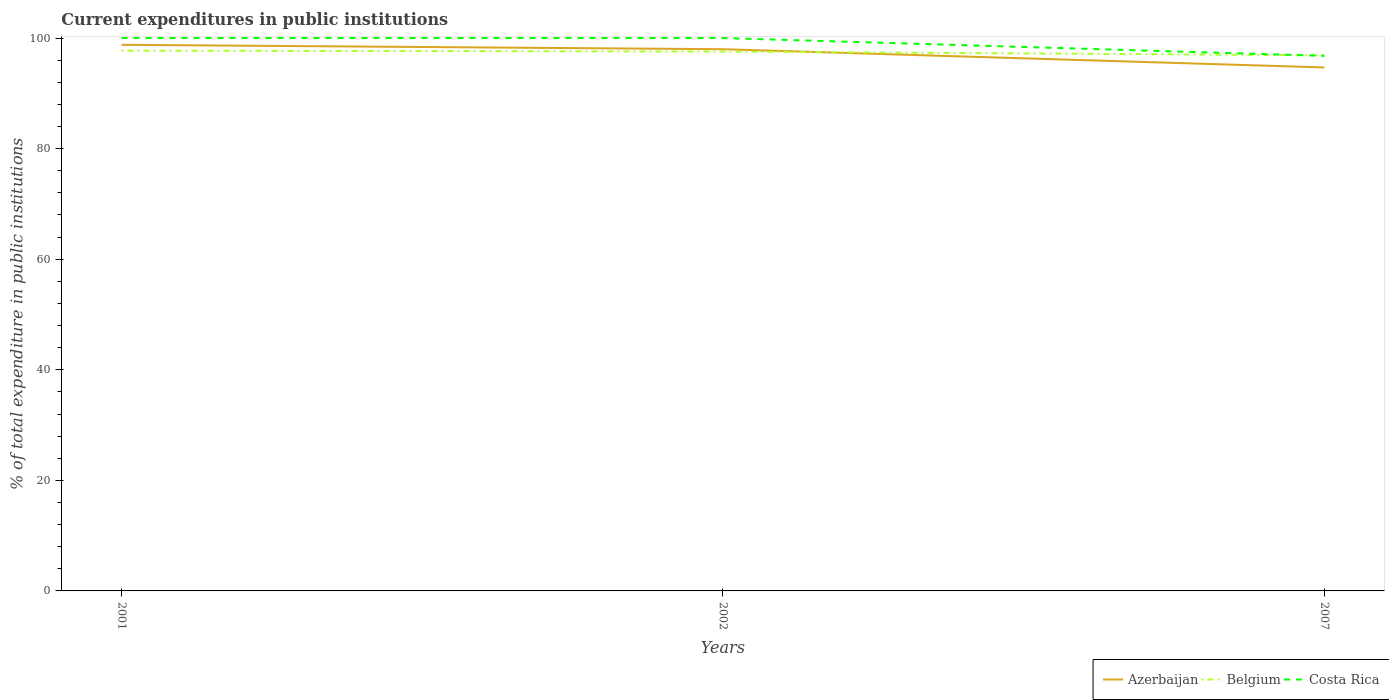How many different coloured lines are there?
Offer a very short reply. 3. Does the line corresponding to Costa Rica intersect with the line corresponding to Belgium?
Provide a short and direct response. Yes. Across all years, what is the maximum current expenditures in public institutions in Azerbaijan?
Your response must be concise. 94.68. In which year was the current expenditures in public institutions in Belgium maximum?
Keep it short and to the point. 2007. What is the difference between the highest and the second highest current expenditures in public institutions in Costa Rica?
Offer a terse response. 3.22. Is the current expenditures in public institutions in Costa Rica strictly greater than the current expenditures in public institutions in Belgium over the years?
Provide a short and direct response. No. What is the difference between two consecutive major ticks on the Y-axis?
Make the answer very short. 20. Does the graph contain grids?
Provide a succinct answer. No. Where does the legend appear in the graph?
Your answer should be very brief. Bottom right. How are the legend labels stacked?
Provide a succinct answer. Horizontal. What is the title of the graph?
Keep it short and to the point. Current expenditures in public institutions. What is the label or title of the X-axis?
Keep it short and to the point. Years. What is the label or title of the Y-axis?
Offer a very short reply. % of total expenditure in public institutions. What is the % of total expenditure in public institutions of Azerbaijan in 2001?
Offer a very short reply. 98.78. What is the % of total expenditure in public institutions in Belgium in 2001?
Give a very brief answer. 97.72. What is the % of total expenditure in public institutions of Costa Rica in 2001?
Give a very brief answer. 100. What is the % of total expenditure in public institutions of Azerbaijan in 2002?
Keep it short and to the point. 97.98. What is the % of total expenditure in public institutions in Belgium in 2002?
Your answer should be compact. 97.56. What is the % of total expenditure in public institutions of Costa Rica in 2002?
Provide a short and direct response. 100. What is the % of total expenditure in public institutions in Azerbaijan in 2007?
Your response must be concise. 94.68. What is the % of total expenditure in public institutions of Belgium in 2007?
Offer a very short reply. 96.88. What is the % of total expenditure in public institutions of Costa Rica in 2007?
Provide a short and direct response. 96.78. Across all years, what is the maximum % of total expenditure in public institutions in Azerbaijan?
Keep it short and to the point. 98.78. Across all years, what is the maximum % of total expenditure in public institutions of Belgium?
Your response must be concise. 97.72. Across all years, what is the minimum % of total expenditure in public institutions in Azerbaijan?
Offer a very short reply. 94.68. Across all years, what is the minimum % of total expenditure in public institutions in Belgium?
Offer a terse response. 96.88. Across all years, what is the minimum % of total expenditure in public institutions in Costa Rica?
Offer a terse response. 96.78. What is the total % of total expenditure in public institutions of Azerbaijan in the graph?
Your answer should be very brief. 291.44. What is the total % of total expenditure in public institutions in Belgium in the graph?
Ensure brevity in your answer.  292.16. What is the total % of total expenditure in public institutions of Costa Rica in the graph?
Provide a succinct answer. 296.78. What is the difference between the % of total expenditure in public institutions of Azerbaijan in 2001 and that in 2002?
Keep it short and to the point. 0.8. What is the difference between the % of total expenditure in public institutions in Belgium in 2001 and that in 2002?
Offer a very short reply. 0.17. What is the difference between the % of total expenditure in public institutions of Costa Rica in 2001 and that in 2002?
Your answer should be compact. 0. What is the difference between the % of total expenditure in public institutions of Azerbaijan in 2001 and that in 2007?
Offer a terse response. 4.1. What is the difference between the % of total expenditure in public institutions in Belgium in 2001 and that in 2007?
Ensure brevity in your answer.  0.84. What is the difference between the % of total expenditure in public institutions of Costa Rica in 2001 and that in 2007?
Keep it short and to the point. 3.22. What is the difference between the % of total expenditure in public institutions of Azerbaijan in 2002 and that in 2007?
Ensure brevity in your answer.  3.3. What is the difference between the % of total expenditure in public institutions in Belgium in 2002 and that in 2007?
Ensure brevity in your answer.  0.67. What is the difference between the % of total expenditure in public institutions in Costa Rica in 2002 and that in 2007?
Provide a short and direct response. 3.22. What is the difference between the % of total expenditure in public institutions of Azerbaijan in 2001 and the % of total expenditure in public institutions of Belgium in 2002?
Offer a very short reply. 1.22. What is the difference between the % of total expenditure in public institutions in Azerbaijan in 2001 and the % of total expenditure in public institutions in Costa Rica in 2002?
Keep it short and to the point. -1.22. What is the difference between the % of total expenditure in public institutions of Belgium in 2001 and the % of total expenditure in public institutions of Costa Rica in 2002?
Provide a succinct answer. -2.28. What is the difference between the % of total expenditure in public institutions of Azerbaijan in 2001 and the % of total expenditure in public institutions of Belgium in 2007?
Provide a short and direct response. 1.9. What is the difference between the % of total expenditure in public institutions in Azerbaijan in 2001 and the % of total expenditure in public institutions in Costa Rica in 2007?
Offer a very short reply. 2. What is the difference between the % of total expenditure in public institutions of Belgium in 2001 and the % of total expenditure in public institutions of Costa Rica in 2007?
Ensure brevity in your answer.  0.94. What is the difference between the % of total expenditure in public institutions in Azerbaijan in 2002 and the % of total expenditure in public institutions in Belgium in 2007?
Keep it short and to the point. 1.1. What is the difference between the % of total expenditure in public institutions in Azerbaijan in 2002 and the % of total expenditure in public institutions in Costa Rica in 2007?
Your answer should be compact. 1.2. What is the difference between the % of total expenditure in public institutions of Belgium in 2002 and the % of total expenditure in public institutions of Costa Rica in 2007?
Provide a short and direct response. 0.78. What is the average % of total expenditure in public institutions in Azerbaijan per year?
Provide a succinct answer. 97.15. What is the average % of total expenditure in public institutions of Belgium per year?
Your answer should be very brief. 97.39. What is the average % of total expenditure in public institutions in Costa Rica per year?
Ensure brevity in your answer.  98.93. In the year 2001, what is the difference between the % of total expenditure in public institutions of Azerbaijan and % of total expenditure in public institutions of Belgium?
Your response must be concise. 1.06. In the year 2001, what is the difference between the % of total expenditure in public institutions of Azerbaijan and % of total expenditure in public institutions of Costa Rica?
Your response must be concise. -1.22. In the year 2001, what is the difference between the % of total expenditure in public institutions in Belgium and % of total expenditure in public institutions in Costa Rica?
Your response must be concise. -2.28. In the year 2002, what is the difference between the % of total expenditure in public institutions of Azerbaijan and % of total expenditure in public institutions of Belgium?
Your response must be concise. 0.43. In the year 2002, what is the difference between the % of total expenditure in public institutions in Azerbaijan and % of total expenditure in public institutions in Costa Rica?
Provide a short and direct response. -2.02. In the year 2002, what is the difference between the % of total expenditure in public institutions in Belgium and % of total expenditure in public institutions in Costa Rica?
Provide a short and direct response. -2.44. In the year 2007, what is the difference between the % of total expenditure in public institutions of Azerbaijan and % of total expenditure in public institutions of Belgium?
Give a very brief answer. -2.2. In the year 2007, what is the difference between the % of total expenditure in public institutions of Azerbaijan and % of total expenditure in public institutions of Costa Rica?
Keep it short and to the point. -2.1. In the year 2007, what is the difference between the % of total expenditure in public institutions of Belgium and % of total expenditure in public institutions of Costa Rica?
Your response must be concise. 0.1. What is the ratio of the % of total expenditure in public institutions of Belgium in 2001 to that in 2002?
Give a very brief answer. 1. What is the ratio of the % of total expenditure in public institutions in Costa Rica in 2001 to that in 2002?
Your response must be concise. 1. What is the ratio of the % of total expenditure in public institutions of Azerbaijan in 2001 to that in 2007?
Give a very brief answer. 1.04. What is the ratio of the % of total expenditure in public institutions of Belgium in 2001 to that in 2007?
Provide a short and direct response. 1.01. What is the ratio of the % of total expenditure in public institutions in Azerbaijan in 2002 to that in 2007?
Ensure brevity in your answer.  1.03. What is the ratio of the % of total expenditure in public institutions in Belgium in 2002 to that in 2007?
Provide a short and direct response. 1.01. What is the difference between the highest and the second highest % of total expenditure in public institutions of Azerbaijan?
Your response must be concise. 0.8. What is the difference between the highest and the second highest % of total expenditure in public institutions in Belgium?
Your answer should be very brief. 0.17. What is the difference between the highest and the second highest % of total expenditure in public institutions of Costa Rica?
Give a very brief answer. 0. What is the difference between the highest and the lowest % of total expenditure in public institutions in Azerbaijan?
Ensure brevity in your answer.  4.1. What is the difference between the highest and the lowest % of total expenditure in public institutions of Belgium?
Offer a terse response. 0.84. What is the difference between the highest and the lowest % of total expenditure in public institutions in Costa Rica?
Offer a terse response. 3.22. 